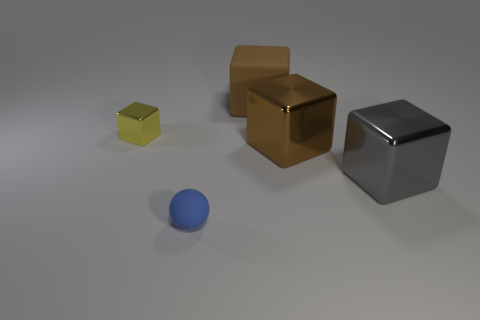Is there anything else that has the same shape as the small rubber thing?
Offer a very short reply. No. How many brown objects have the same size as the blue matte object?
Your answer should be very brief. 0. There is a rubber object behind the yellow thing; is it the same size as the brown metallic thing?
Your answer should be very brief. Yes. What is the shape of the tiny matte thing?
Give a very brief answer. Sphere. The metallic cube that is the same color as the matte cube is what size?
Ensure brevity in your answer.  Large. Is the material of the brown cube in front of the tiny yellow metallic thing the same as the small sphere?
Offer a very short reply. No. Are there any other big blocks that have the same color as the large rubber block?
Your response must be concise. Yes. Do the brown thing behind the yellow shiny object and the rubber object left of the brown rubber thing have the same shape?
Offer a very short reply. No. Are there any brown cubes that have the same material as the yellow object?
Keep it short and to the point. Yes. How many brown things are big shiny blocks or large things?
Provide a succinct answer. 2. 